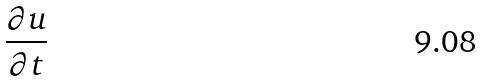Convert formula to latex. <formula><loc_0><loc_0><loc_500><loc_500>\frac { \partial u } { \partial t }</formula> 